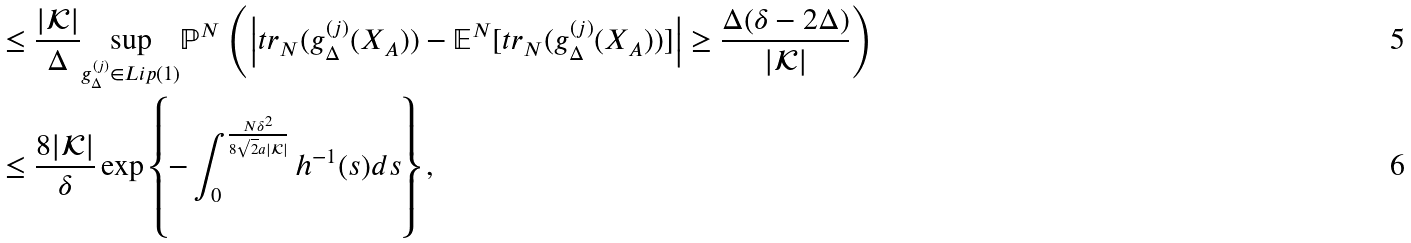Convert formula to latex. <formula><loc_0><loc_0><loc_500><loc_500>& \leq \frac { | \mathcal { K } | } { \Delta } \underset { g ^ { ( j ) } _ { \Delta } \in L i p ( 1 ) } { \sup } \mathbb { P } ^ { N } \left ( \left | t r _ { N } ( g ^ { ( j ) } _ { \Delta } ( { X _ { A } } ) ) - \mathbb { E } ^ { N } [ t r _ { N } ( g ^ { ( j ) } _ { \Delta } ( { X _ { A } } ) ) ] \right | \geq \frac { \Delta ( \delta - 2 \Delta ) } { | \mathcal { K } | } \right ) \\ & \leq \frac { 8 | \mathcal { K } | } { \delta } \exp \left \{ - \int _ { 0 } ^ { \frac { N \delta ^ { 2 } } { 8 \sqrt { 2 } a | \mathcal { K } | } } h ^ { - 1 } ( s ) d s \right \} ,</formula> 